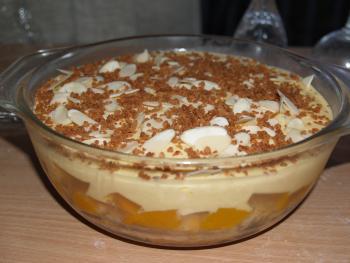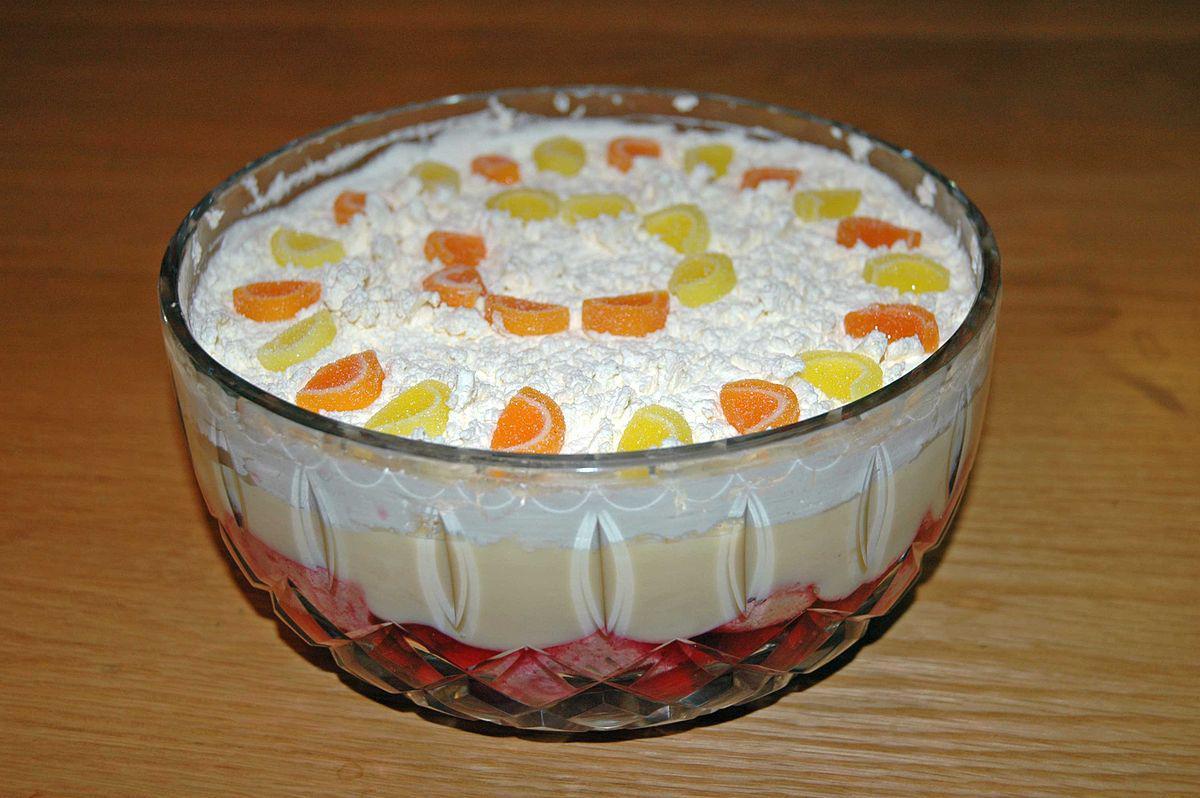The first image is the image on the left, the second image is the image on the right. Given the left and right images, does the statement "at least one trifle dessert has fruit on top" hold true? Answer yes or no. Yes. 